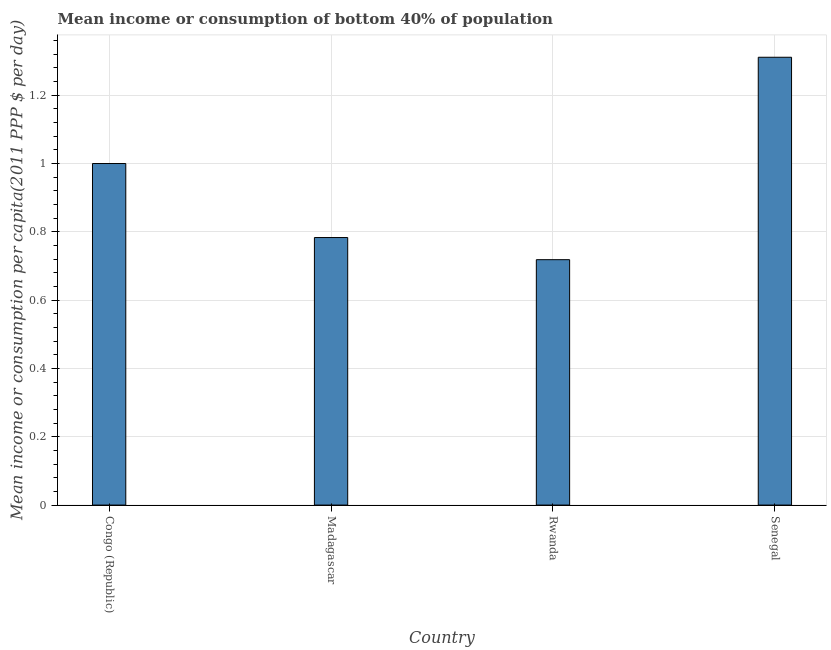Does the graph contain any zero values?
Ensure brevity in your answer.  No. Does the graph contain grids?
Provide a succinct answer. Yes. What is the title of the graph?
Your response must be concise. Mean income or consumption of bottom 40% of population. What is the label or title of the Y-axis?
Provide a short and direct response. Mean income or consumption per capita(2011 PPP $ per day). What is the mean income or consumption in Congo (Republic)?
Your answer should be very brief. 1. Across all countries, what is the maximum mean income or consumption?
Give a very brief answer. 1.31. Across all countries, what is the minimum mean income or consumption?
Your answer should be very brief. 0.72. In which country was the mean income or consumption maximum?
Your answer should be compact. Senegal. In which country was the mean income or consumption minimum?
Your answer should be compact. Rwanda. What is the sum of the mean income or consumption?
Provide a short and direct response. 3.81. What is the difference between the mean income or consumption in Congo (Republic) and Madagascar?
Make the answer very short. 0.22. What is the average mean income or consumption per country?
Make the answer very short. 0.95. What is the median mean income or consumption?
Your answer should be compact. 0.89. What is the ratio of the mean income or consumption in Congo (Republic) to that in Madagascar?
Provide a short and direct response. 1.28. What is the difference between the highest and the second highest mean income or consumption?
Give a very brief answer. 0.31. Is the sum of the mean income or consumption in Congo (Republic) and Madagascar greater than the maximum mean income or consumption across all countries?
Make the answer very short. Yes. What is the difference between the highest and the lowest mean income or consumption?
Offer a very short reply. 0.59. How many bars are there?
Ensure brevity in your answer.  4. Are all the bars in the graph horizontal?
Offer a very short reply. No. What is the Mean income or consumption per capita(2011 PPP $ per day) in Congo (Republic)?
Make the answer very short. 1. What is the Mean income or consumption per capita(2011 PPP $ per day) of Madagascar?
Your answer should be very brief. 0.78. What is the Mean income or consumption per capita(2011 PPP $ per day) in Rwanda?
Offer a very short reply. 0.72. What is the Mean income or consumption per capita(2011 PPP $ per day) in Senegal?
Give a very brief answer. 1.31. What is the difference between the Mean income or consumption per capita(2011 PPP $ per day) in Congo (Republic) and Madagascar?
Provide a short and direct response. 0.22. What is the difference between the Mean income or consumption per capita(2011 PPP $ per day) in Congo (Republic) and Rwanda?
Make the answer very short. 0.28. What is the difference between the Mean income or consumption per capita(2011 PPP $ per day) in Congo (Republic) and Senegal?
Ensure brevity in your answer.  -0.31. What is the difference between the Mean income or consumption per capita(2011 PPP $ per day) in Madagascar and Rwanda?
Your response must be concise. 0.06. What is the difference between the Mean income or consumption per capita(2011 PPP $ per day) in Madagascar and Senegal?
Keep it short and to the point. -0.53. What is the difference between the Mean income or consumption per capita(2011 PPP $ per day) in Rwanda and Senegal?
Provide a succinct answer. -0.59. What is the ratio of the Mean income or consumption per capita(2011 PPP $ per day) in Congo (Republic) to that in Madagascar?
Keep it short and to the point. 1.28. What is the ratio of the Mean income or consumption per capita(2011 PPP $ per day) in Congo (Republic) to that in Rwanda?
Keep it short and to the point. 1.39. What is the ratio of the Mean income or consumption per capita(2011 PPP $ per day) in Congo (Republic) to that in Senegal?
Keep it short and to the point. 0.76. What is the ratio of the Mean income or consumption per capita(2011 PPP $ per day) in Madagascar to that in Rwanda?
Ensure brevity in your answer.  1.09. What is the ratio of the Mean income or consumption per capita(2011 PPP $ per day) in Madagascar to that in Senegal?
Give a very brief answer. 0.6. What is the ratio of the Mean income or consumption per capita(2011 PPP $ per day) in Rwanda to that in Senegal?
Give a very brief answer. 0.55. 